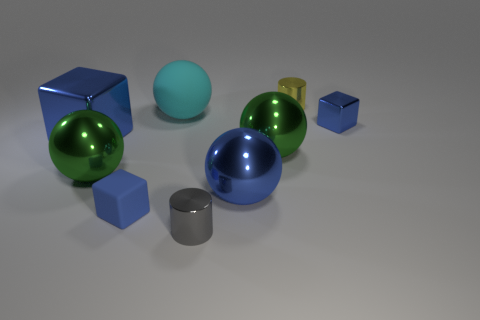Subtract all cyan spheres. How many spheres are left? 3 Subtract all green balls. How many balls are left? 2 Subtract 3 balls. How many balls are left? 1 Add 1 yellow cylinders. How many objects exist? 10 Subtract all balls. How many objects are left? 5 Subtract all yellow blocks. How many green balls are left? 2 Add 7 green things. How many green things exist? 9 Subtract 0 brown balls. How many objects are left? 9 Subtract all blue cylinders. Subtract all purple spheres. How many cylinders are left? 2 Subtract all big cyan things. Subtract all large metallic objects. How many objects are left? 4 